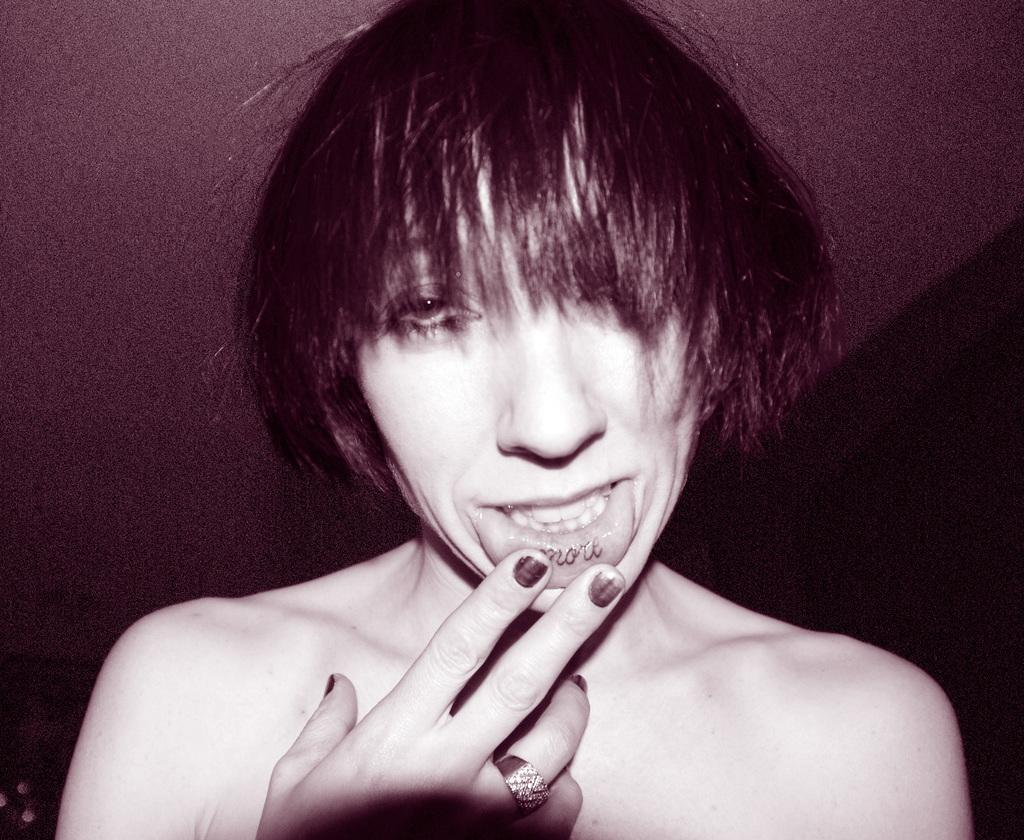What is the main subject of the image? The main subject of the image is a woman. What is the woman doing in the image? The woman has her fingers on her lips. What type of bomb is the woman holding in the image? There is no bomb present in the image; the woman has her fingers on her lips. What is the woman using the wrench for in the image? There is no wrench present in the image; the woman has her fingers on her lips. 